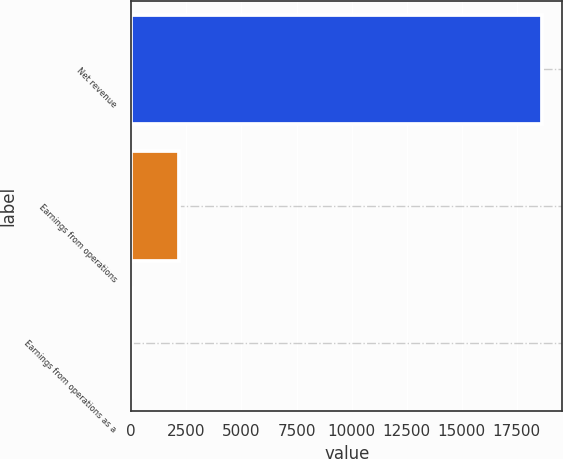Convert chart. <chart><loc_0><loc_0><loc_500><loc_500><bar_chart><fcel>Net revenue<fcel>Earnings from operations<fcel>Earnings from operations as a<nl><fcel>18639<fcel>2148<fcel>11.5<nl></chart> 